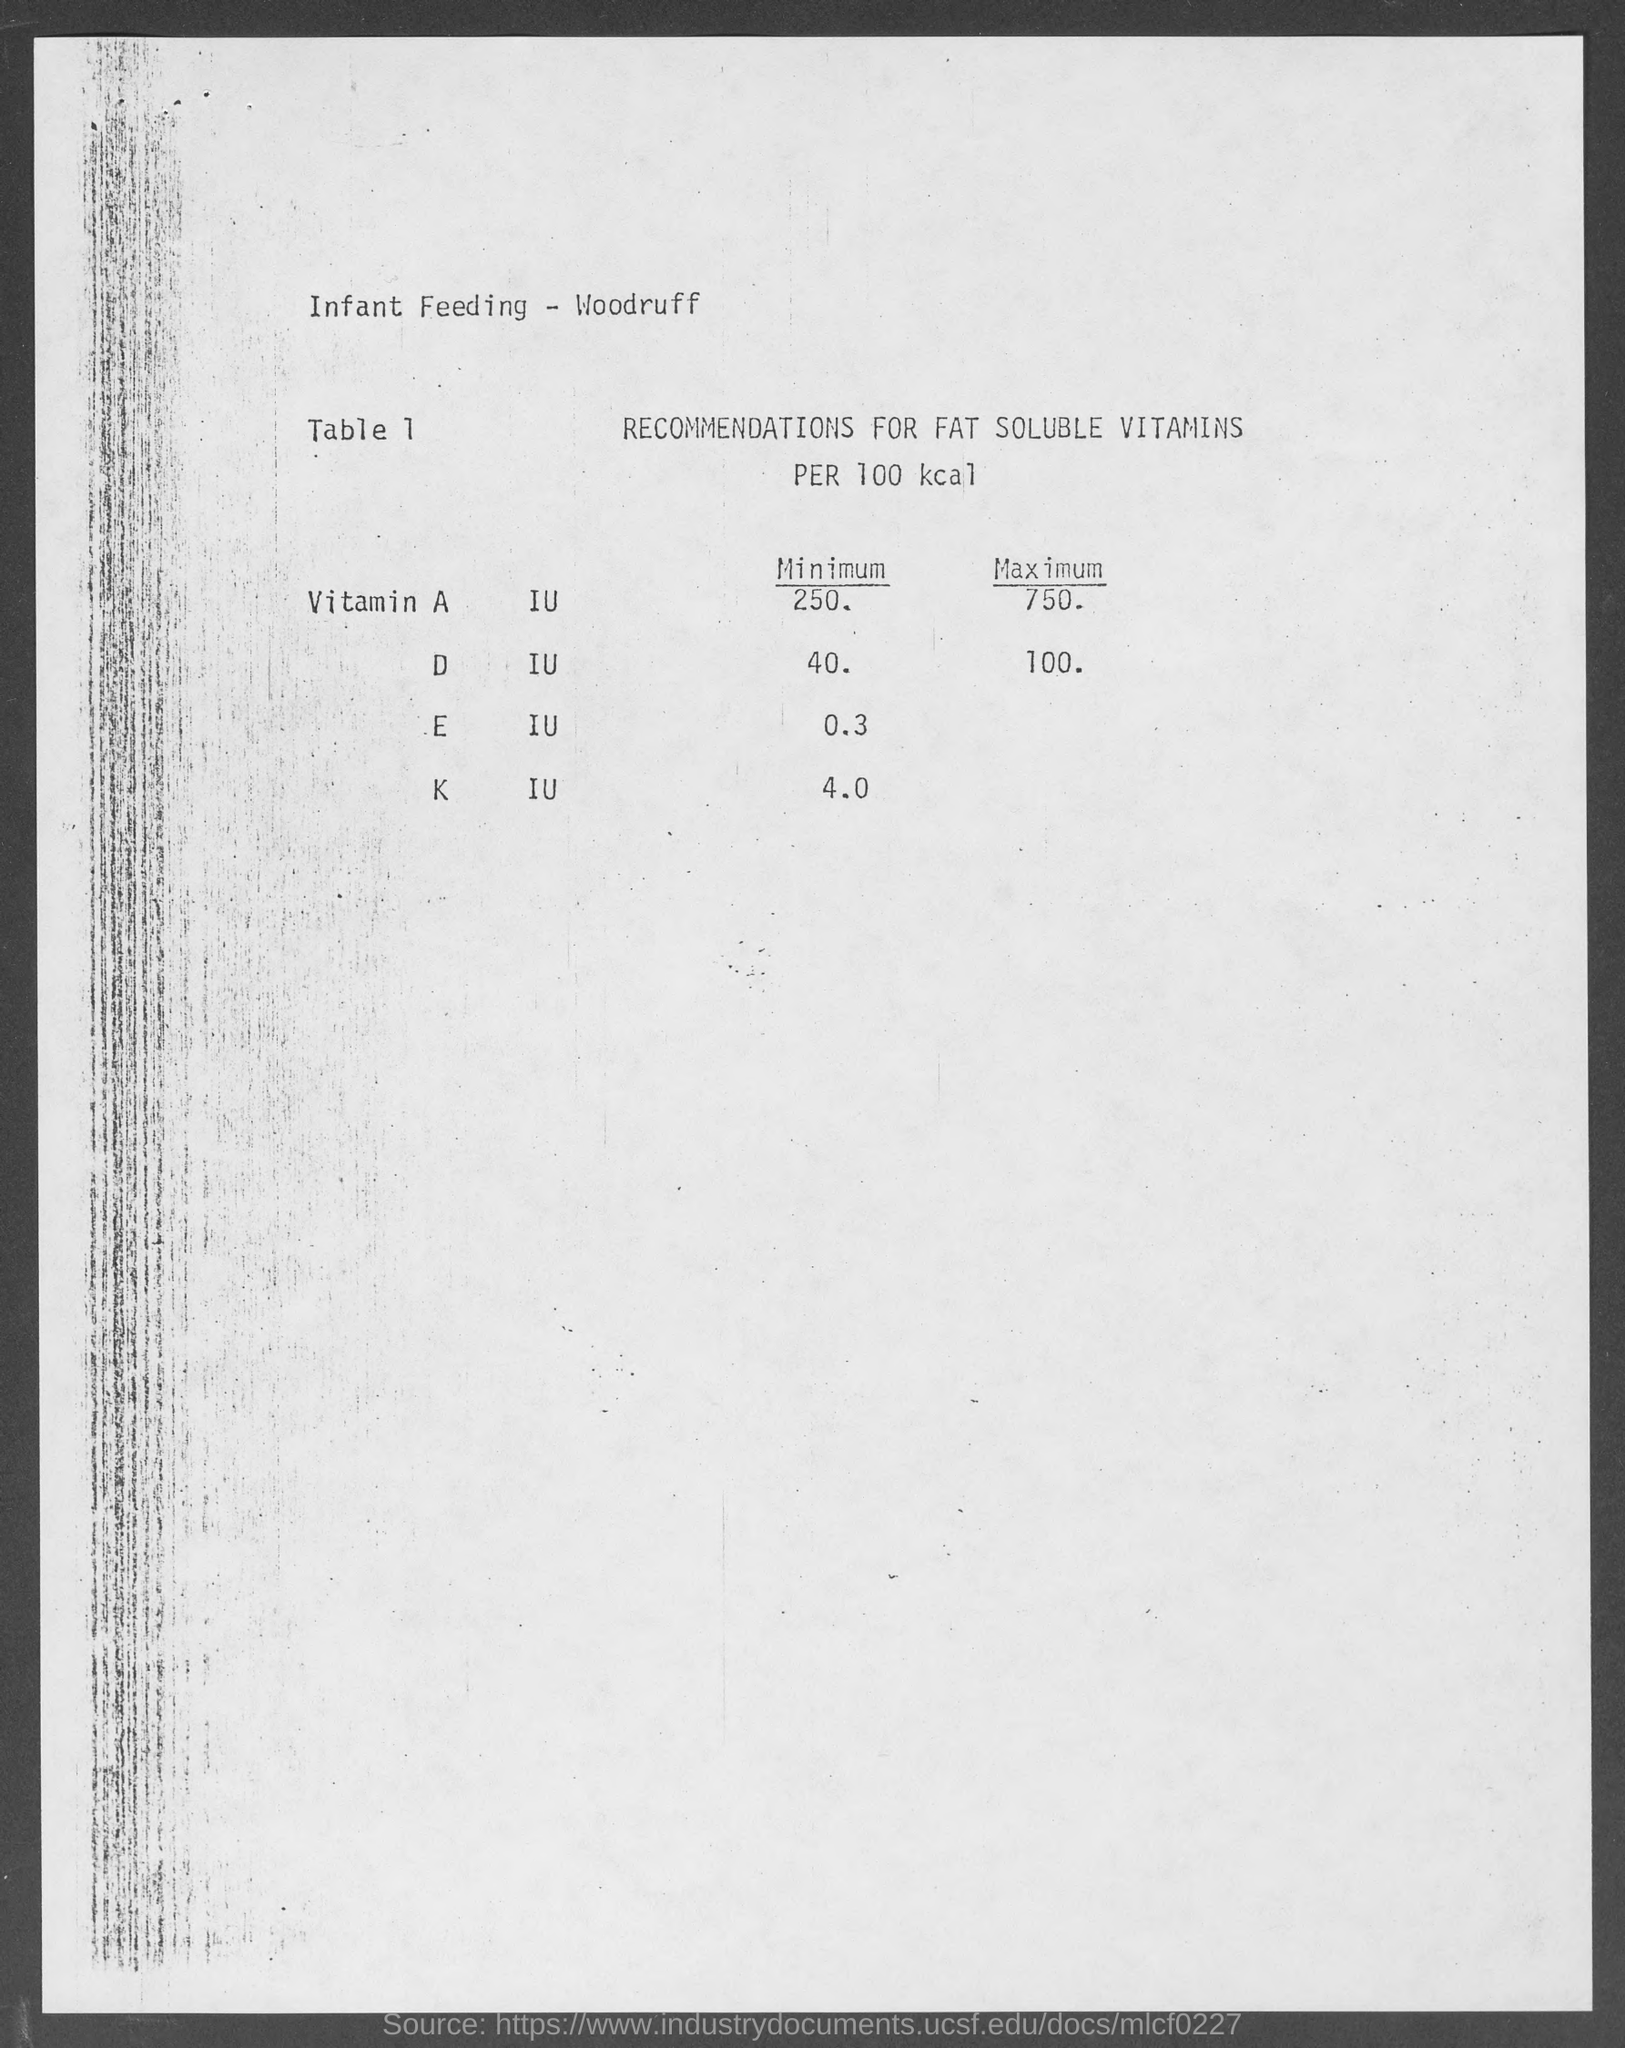Specify some key components in this picture. The title of table 1 is 'Recommendations for Fat Soluble Vitamins per 100 kcal...' 